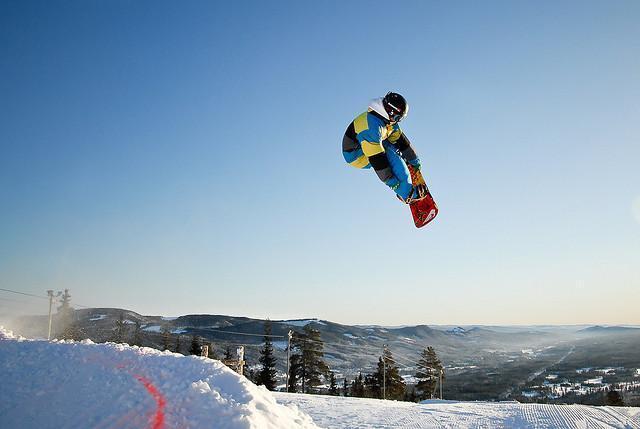How many cars are in the picture?
Give a very brief answer. 0. 